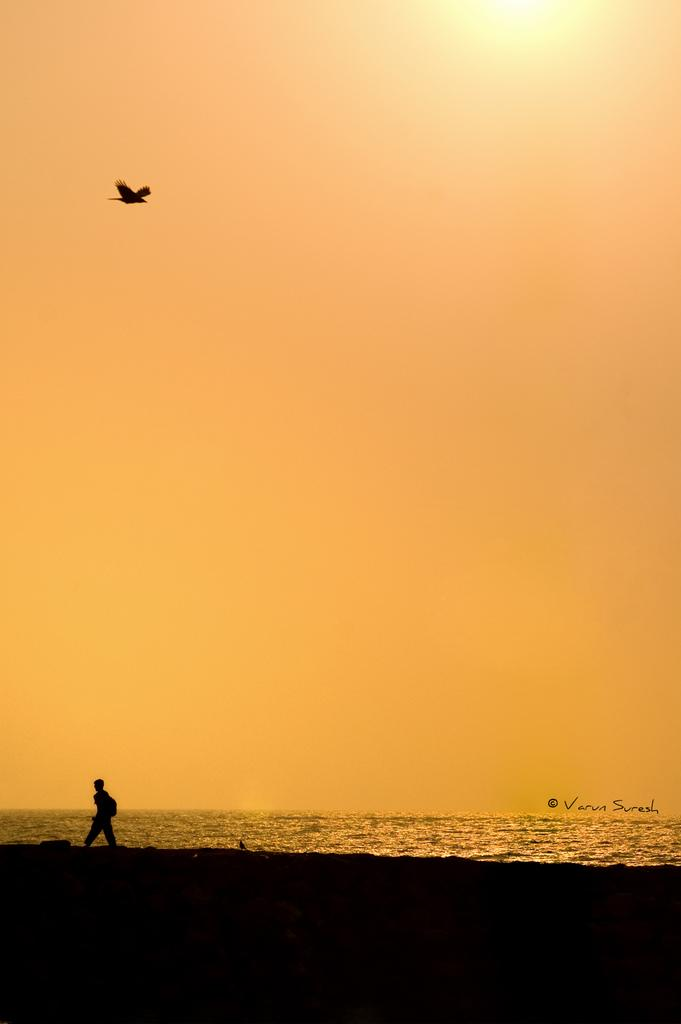What is the main subject of the image? There is a person standing in the image. What can be seen in the background of the image? There is water visible in the image. What is the bird doing in the image? There is a bird flying in the image. What is the color of the sky in the image? The sky is yellow in color. Reasoning: Let' Let's think step by step in order to produce the conversation. We start by identifying the main subject of the image, which is the person standing. Then, we describe the background, which includes water. Next, we mention the bird and its action, which is flying. Finally, we note the unique color of the sky, which is yellow. Absurd Question/Answer: How many frogs are sitting on the throne in the image? There is no throne or frogs present in the image. What type of burst can be seen in the image? There is no burst present in the image. 